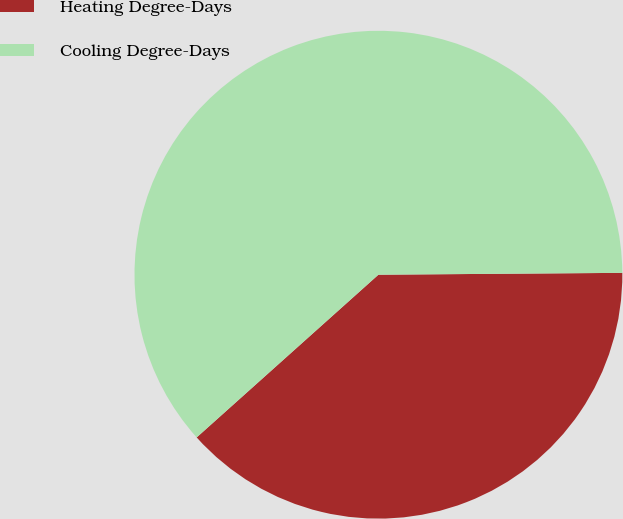<chart> <loc_0><loc_0><loc_500><loc_500><pie_chart><fcel>Heating Degree-Days<fcel>Cooling Degree-Days<nl><fcel>38.5%<fcel>61.5%<nl></chart> 